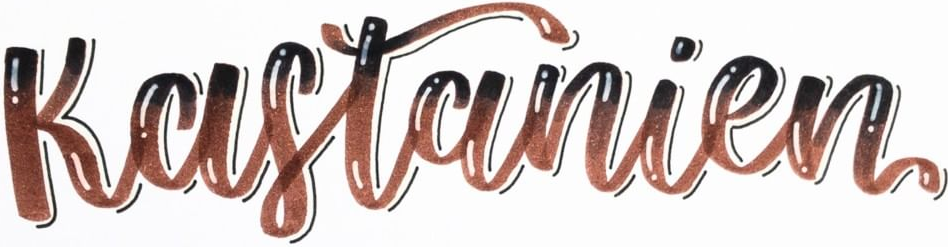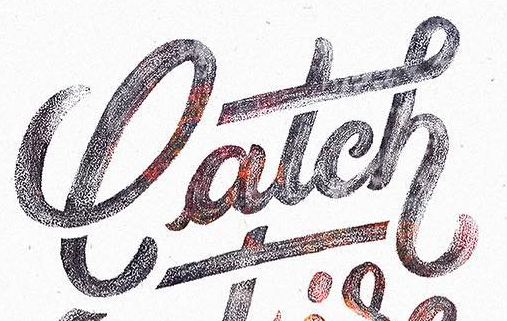What text is displayed in these images sequentially, separated by a semicolon? Kastanien; latch 